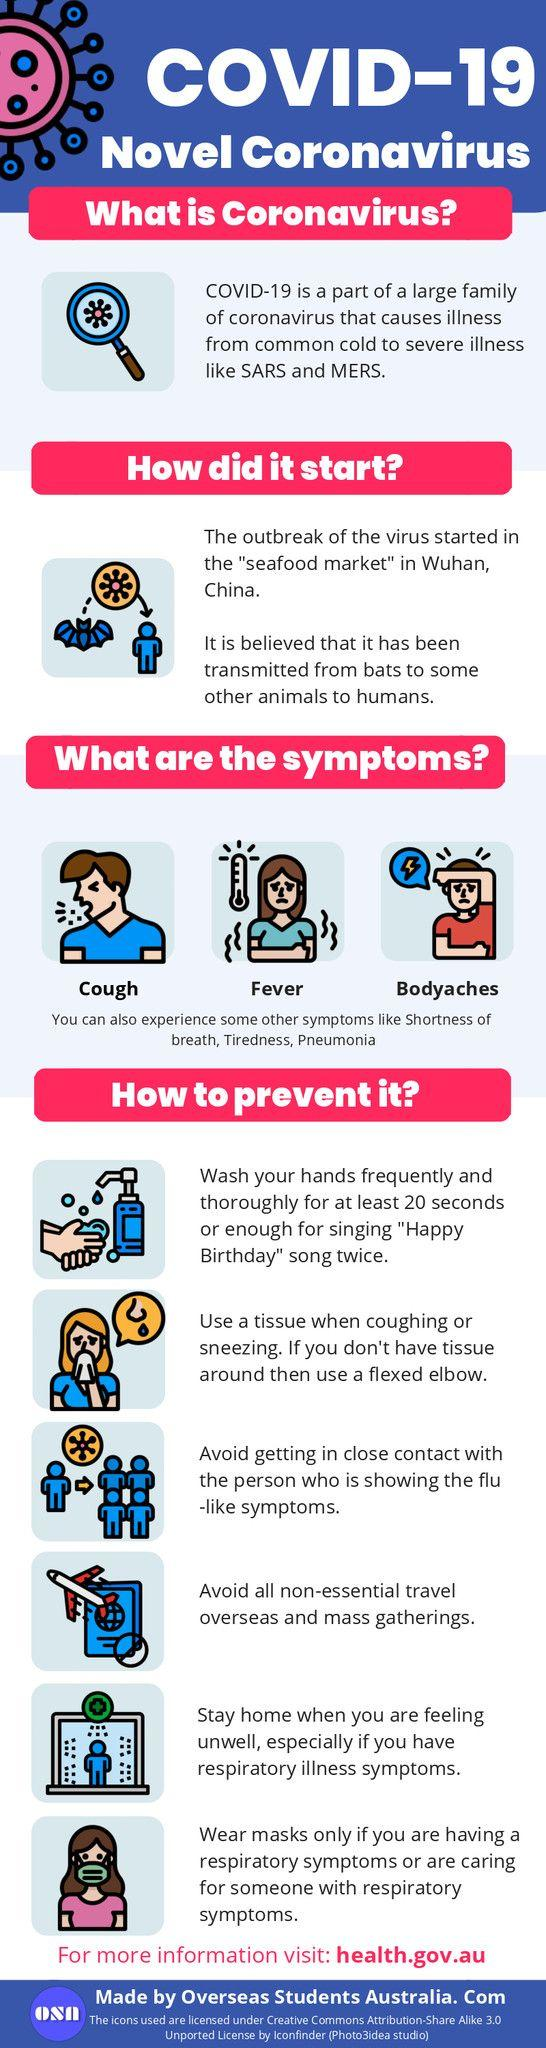Outline some significant characteristics in this image. Six symptoms have been listed. 